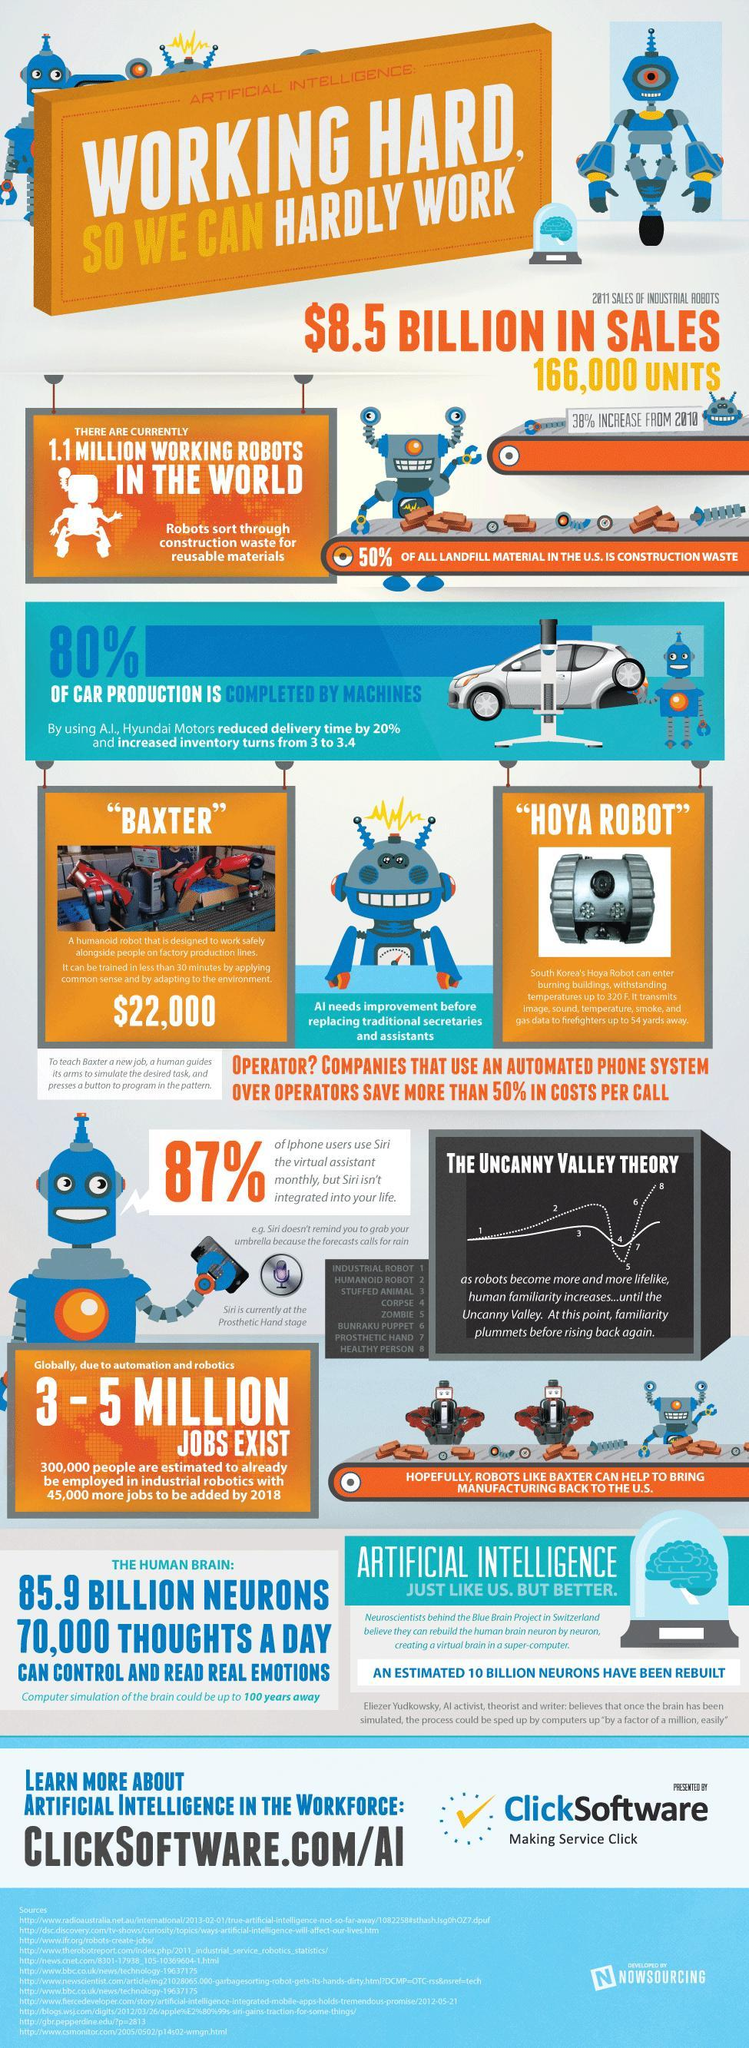What percentage of car production is not completed by machines?
Answer the question with a short phrase. 20% What percentage of iPhone users didn't use "Siri" the virtual assistant monthly? 13% 